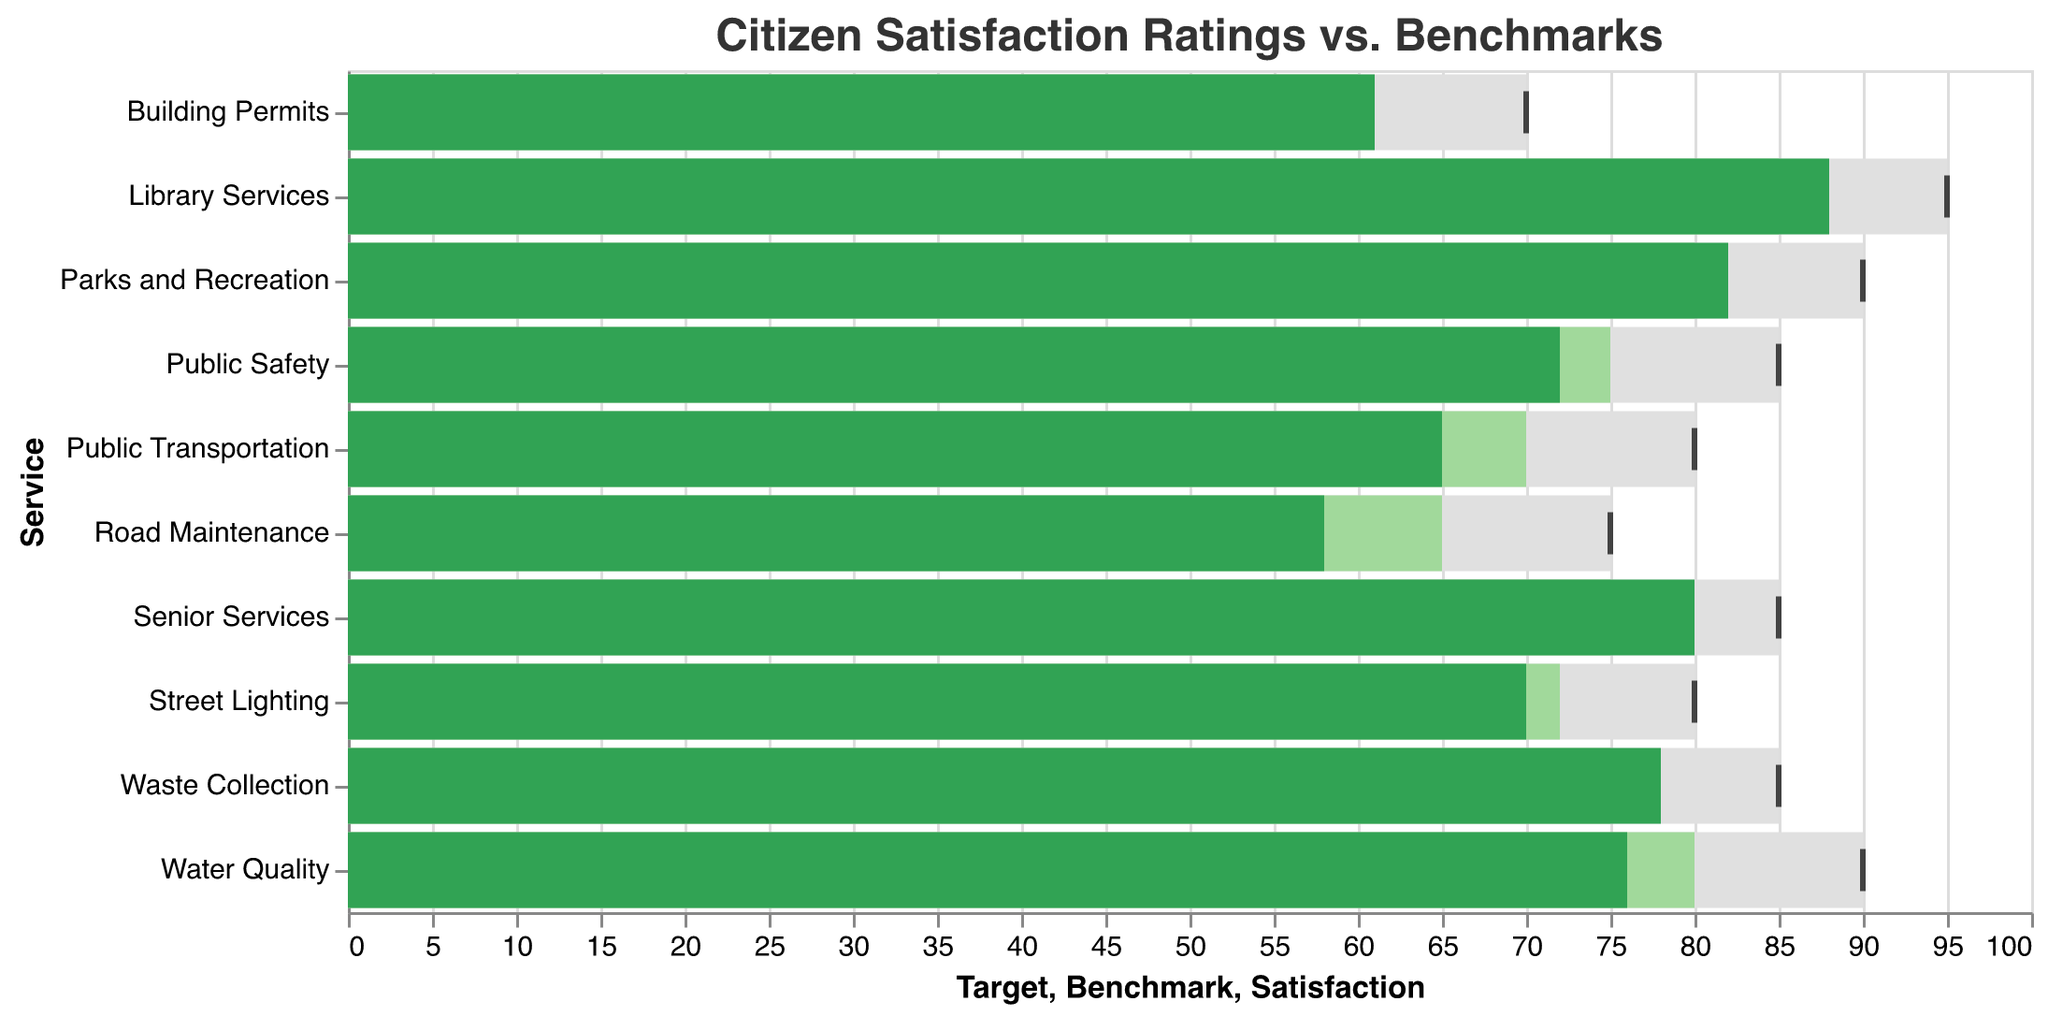What is the title of the figure? The title is typically found at the top of the chart. It is used to summarize the content of the figure. In this chart, the title is clearly visible at the top.
Answer: Citizen Satisfaction Ratings vs. Benchmarks Which municipal service has the highest satisfaction rating? To find the highest satisfaction rating, look for the longest green bar in the chart which represents satisfaction ratings.
Answer: Library Services How does the satisfaction rating for Road Maintenance compare to its benchmark? Locate the bars for Road Maintenance. Notice that its satisfaction rating bar (green) is shorter than the benchmark bar (light green).
Answer: Below benchmark What are the satisfaction and benchmark ratings for Waste Collection? Identify the position of the Waste Collection service on the y-axis. Note the length of the green and light green bars to determine the ratings.
Answer: 78 and 75 Which service has a satisfaction rating that meets or exceeds its target? Compare the green satisfaction bars to the benchmark tick marks for each service. Parks and Recreation is one such service where the satisfaction surpasses the target.
Answer: Parks and Recreation What is the difference between satisfaction and target for Public Transportation? Locate Public Transportation on the y-axis. Subtract the satisfaction value from the target value: 80 - 65.
Answer: 15 Which municipal service has the largest gap between satisfaction and benchmark? Calculate the difference for each service by subtracting the benchmark value from the satisfaction value. The largest negative difference is found for Road Maintenance.
Answer: Road Maintenance Between Waste Collection and Water Quality, which has a higher rank in satisfaction ratings? Compare the lengths of the green satisfaction bars for Waste Collection and Water Quality. Waste Collection's bar is longer.
Answer: Waste Collection What is the average satisfaction rating across all municipal services? Sum all satisfaction ratings and divide by the number of services: (78 + 65 + 82 + 58 + 72 + 88 + 61 + 76 + 70 + 80) / 10.
Answer: 73 